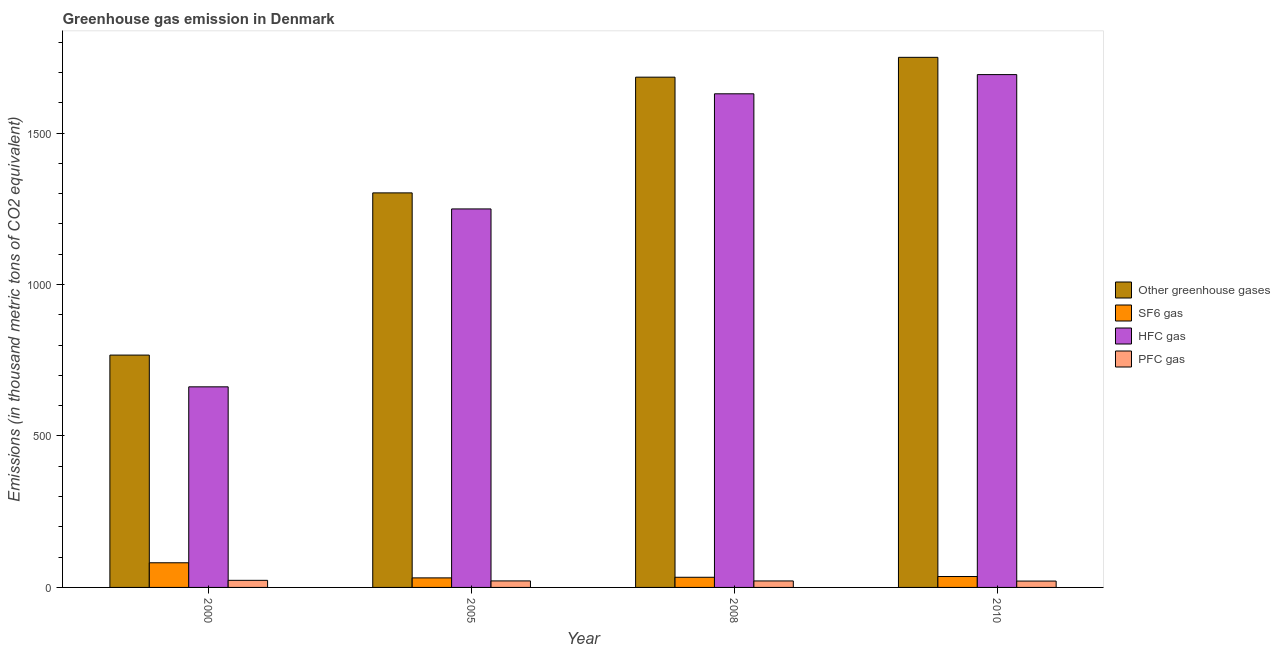How many groups of bars are there?
Give a very brief answer. 4. How many bars are there on the 3rd tick from the right?
Your response must be concise. 4. What is the emission of greenhouse gases in 2000?
Provide a short and direct response. 767. Across all years, what is the maximum emission of sf6 gas?
Your answer should be very brief. 81.4. Across all years, what is the minimum emission of hfc gas?
Provide a succinct answer. 662.2. What is the total emission of hfc gas in the graph?
Your response must be concise. 5234.3. What is the difference between the emission of hfc gas in 2008 and the emission of sf6 gas in 2000?
Your answer should be compact. 967.4. What is the average emission of greenhouse gases per year?
Your answer should be compact. 1376. In the year 2008, what is the difference between the emission of greenhouse gases and emission of hfc gas?
Keep it short and to the point. 0. What is the ratio of the emission of pfc gas in 2008 to that in 2010?
Ensure brevity in your answer.  1.02. Is the difference between the emission of sf6 gas in 2005 and 2010 greater than the difference between the emission of hfc gas in 2005 and 2010?
Your answer should be very brief. No. What is the difference between the highest and the second highest emission of pfc gas?
Provide a succinct answer. 1.9. What is the difference between the highest and the lowest emission of hfc gas?
Give a very brief answer. 1030.8. In how many years, is the emission of pfc gas greater than the average emission of pfc gas taken over all years?
Provide a short and direct response. 1. Is the sum of the emission of greenhouse gases in 2005 and 2010 greater than the maximum emission of pfc gas across all years?
Offer a terse response. Yes. Is it the case that in every year, the sum of the emission of pfc gas and emission of greenhouse gases is greater than the sum of emission of hfc gas and emission of sf6 gas?
Ensure brevity in your answer.  No. What does the 4th bar from the left in 2008 represents?
Ensure brevity in your answer.  PFC gas. What does the 2nd bar from the right in 2000 represents?
Your answer should be compact. HFC gas. Is it the case that in every year, the sum of the emission of greenhouse gases and emission of sf6 gas is greater than the emission of hfc gas?
Offer a terse response. Yes. How many bars are there?
Give a very brief answer. 16. Are all the bars in the graph horizontal?
Ensure brevity in your answer.  No. How many years are there in the graph?
Make the answer very short. 4. Does the graph contain grids?
Give a very brief answer. No. How are the legend labels stacked?
Keep it short and to the point. Vertical. What is the title of the graph?
Your answer should be very brief. Greenhouse gas emission in Denmark. Does "Austria" appear as one of the legend labels in the graph?
Offer a terse response. No. What is the label or title of the Y-axis?
Provide a short and direct response. Emissions (in thousand metric tons of CO2 equivalent). What is the Emissions (in thousand metric tons of CO2 equivalent) in Other greenhouse gases in 2000?
Make the answer very short. 767. What is the Emissions (in thousand metric tons of CO2 equivalent) in SF6 gas in 2000?
Offer a terse response. 81.4. What is the Emissions (in thousand metric tons of CO2 equivalent) of HFC gas in 2000?
Ensure brevity in your answer.  662.2. What is the Emissions (in thousand metric tons of CO2 equivalent) of PFC gas in 2000?
Offer a terse response. 23.4. What is the Emissions (in thousand metric tons of CO2 equivalent) in Other greenhouse gases in 2005?
Your answer should be very brief. 1302.5. What is the Emissions (in thousand metric tons of CO2 equivalent) of SF6 gas in 2005?
Provide a short and direct response. 31.5. What is the Emissions (in thousand metric tons of CO2 equivalent) of HFC gas in 2005?
Your response must be concise. 1249.5. What is the Emissions (in thousand metric tons of CO2 equivalent) of PFC gas in 2005?
Offer a terse response. 21.5. What is the Emissions (in thousand metric tons of CO2 equivalent) in Other greenhouse gases in 2008?
Offer a terse response. 1684.5. What is the Emissions (in thousand metric tons of CO2 equivalent) of SF6 gas in 2008?
Your response must be concise. 33.5. What is the Emissions (in thousand metric tons of CO2 equivalent) in HFC gas in 2008?
Your response must be concise. 1629.6. What is the Emissions (in thousand metric tons of CO2 equivalent) in PFC gas in 2008?
Keep it short and to the point. 21.4. What is the Emissions (in thousand metric tons of CO2 equivalent) of Other greenhouse gases in 2010?
Your answer should be compact. 1750. What is the Emissions (in thousand metric tons of CO2 equivalent) in SF6 gas in 2010?
Keep it short and to the point. 36. What is the Emissions (in thousand metric tons of CO2 equivalent) of HFC gas in 2010?
Give a very brief answer. 1693. What is the Emissions (in thousand metric tons of CO2 equivalent) of PFC gas in 2010?
Offer a very short reply. 21. Across all years, what is the maximum Emissions (in thousand metric tons of CO2 equivalent) of Other greenhouse gases?
Your answer should be very brief. 1750. Across all years, what is the maximum Emissions (in thousand metric tons of CO2 equivalent) in SF6 gas?
Offer a terse response. 81.4. Across all years, what is the maximum Emissions (in thousand metric tons of CO2 equivalent) of HFC gas?
Your response must be concise. 1693. Across all years, what is the maximum Emissions (in thousand metric tons of CO2 equivalent) in PFC gas?
Make the answer very short. 23.4. Across all years, what is the minimum Emissions (in thousand metric tons of CO2 equivalent) of Other greenhouse gases?
Offer a terse response. 767. Across all years, what is the minimum Emissions (in thousand metric tons of CO2 equivalent) of SF6 gas?
Provide a succinct answer. 31.5. Across all years, what is the minimum Emissions (in thousand metric tons of CO2 equivalent) in HFC gas?
Ensure brevity in your answer.  662.2. What is the total Emissions (in thousand metric tons of CO2 equivalent) of Other greenhouse gases in the graph?
Keep it short and to the point. 5504. What is the total Emissions (in thousand metric tons of CO2 equivalent) in SF6 gas in the graph?
Keep it short and to the point. 182.4. What is the total Emissions (in thousand metric tons of CO2 equivalent) of HFC gas in the graph?
Provide a succinct answer. 5234.3. What is the total Emissions (in thousand metric tons of CO2 equivalent) of PFC gas in the graph?
Provide a short and direct response. 87.3. What is the difference between the Emissions (in thousand metric tons of CO2 equivalent) of Other greenhouse gases in 2000 and that in 2005?
Your response must be concise. -535.5. What is the difference between the Emissions (in thousand metric tons of CO2 equivalent) in SF6 gas in 2000 and that in 2005?
Ensure brevity in your answer.  49.9. What is the difference between the Emissions (in thousand metric tons of CO2 equivalent) in HFC gas in 2000 and that in 2005?
Give a very brief answer. -587.3. What is the difference between the Emissions (in thousand metric tons of CO2 equivalent) of PFC gas in 2000 and that in 2005?
Offer a terse response. 1.9. What is the difference between the Emissions (in thousand metric tons of CO2 equivalent) of Other greenhouse gases in 2000 and that in 2008?
Keep it short and to the point. -917.5. What is the difference between the Emissions (in thousand metric tons of CO2 equivalent) in SF6 gas in 2000 and that in 2008?
Provide a short and direct response. 47.9. What is the difference between the Emissions (in thousand metric tons of CO2 equivalent) of HFC gas in 2000 and that in 2008?
Your answer should be very brief. -967.4. What is the difference between the Emissions (in thousand metric tons of CO2 equivalent) in PFC gas in 2000 and that in 2008?
Offer a terse response. 2. What is the difference between the Emissions (in thousand metric tons of CO2 equivalent) in Other greenhouse gases in 2000 and that in 2010?
Make the answer very short. -983. What is the difference between the Emissions (in thousand metric tons of CO2 equivalent) in SF6 gas in 2000 and that in 2010?
Your answer should be very brief. 45.4. What is the difference between the Emissions (in thousand metric tons of CO2 equivalent) of HFC gas in 2000 and that in 2010?
Your answer should be compact. -1030.8. What is the difference between the Emissions (in thousand metric tons of CO2 equivalent) of PFC gas in 2000 and that in 2010?
Your answer should be very brief. 2.4. What is the difference between the Emissions (in thousand metric tons of CO2 equivalent) of Other greenhouse gases in 2005 and that in 2008?
Provide a succinct answer. -382. What is the difference between the Emissions (in thousand metric tons of CO2 equivalent) in HFC gas in 2005 and that in 2008?
Give a very brief answer. -380.1. What is the difference between the Emissions (in thousand metric tons of CO2 equivalent) in Other greenhouse gases in 2005 and that in 2010?
Make the answer very short. -447.5. What is the difference between the Emissions (in thousand metric tons of CO2 equivalent) of SF6 gas in 2005 and that in 2010?
Give a very brief answer. -4.5. What is the difference between the Emissions (in thousand metric tons of CO2 equivalent) in HFC gas in 2005 and that in 2010?
Make the answer very short. -443.5. What is the difference between the Emissions (in thousand metric tons of CO2 equivalent) of PFC gas in 2005 and that in 2010?
Provide a succinct answer. 0.5. What is the difference between the Emissions (in thousand metric tons of CO2 equivalent) of Other greenhouse gases in 2008 and that in 2010?
Provide a short and direct response. -65.5. What is the difference between the Emissions (in thousand metric tons of CO2 equivalent) of HFC gas in 2008 and that in 2010?
Your answer should be compact. -63.4. What is the difference between the Emissions (in thousand metric tons of CO2 equivalent) in PFC gas in 2008 and that in 2010?
Offer a very short reply. 0.4. What is the difference between the Emissions (in thousand metric tons of CO2 equivalent) of Other greenhouse gases in 2000 and the Emissions (in thousand metric tons of CO2 equivalent) of SF6 gas in 2005?
Provide a short and direct response. 735.5. What is the difference between the Emissions (in thousand metric tons of CO2 equivalent) in Other greenhouse gases in 2000 and the Emissions (in thousand metric tons of CO2 equivalent) in HFC gas in 2005?
Your response must be concise. -482.5. What is the difference between the Emissions (in thousand metric tons of CO2 equivalent) of Other greenhouse gases in 2000 and the Emissions (in thousand metric tons of CO2 equivalent) of PFC gas in 2005?
Your response must be concise. 745.5. What is the difference between the Emissions (in thousand metric tons of CO2 equivalent) in SF6 gas in 2000 and the Emissions (in thousand metric tons of CO2 equivalent) in HFC gas in 2005?
Provide a succinct answer. -1168.1. What is the difference between the Emissions (in thousand metric tons of CO2 equivalent) in SF6 gas in 2000 and the Emissions (in thousand metric tons of CO2 equivalent) in PFC gas in 2005?
Your response must be concise. 59.9. What is the difference between the Emissions (in thousand metric tons of CO2 equivalent) of HFC gas in 2000 and the Emissions (in thousand metric tons of CO2 equivalent) of PFC gas in 2005?
Give a very brief answer. 640.7. What is the difference between the Emissions (in thousand metric tons of CO2 equivalent) of Other greenhouse gases in 2000 and the Emissions (in thousand metric tons of CO2 equivalent) of SF6 gas in 2008?
Your answer should be very brief. 733.5. What is the difference between the Emissions (in thousand metric tons of CO2 equivalent) of Other greenhouse gases in 2000 and the Emissions (in thousand metric tons of CO2 equivalent) of HFC gas in 2008?
Keep it short and to the point. -862.6. What is the difference between the Emissions (in thousand metric tons of CO2 equivalent) of Other greenhouse gases in 2000 and the Emissions (in thousand metric tons of CO2 equivalent) of PFC gas in 2008?
Give a very brief answer. 745.6. What is the difference between the Emissions (in thousand metric tons of CO2 equivalent) in SF6 gas in 2000 and the Emissions (in thousand metric tons of CO2 equivalent) in HFC gas in 2008?
Offer a very short reply. -1548.2. What is the difference between the Emissions (in thousand metric tons of CO2 equivalent) of HFC gas in 2000 and the Emissions (in thousand metric tons of CO2 equivalent) of PFC gas in 2008?
Your response must be concise. 640.8. What is the difference between the Emissions (in thousand metric tons of CO2 equivalent) of Other greenhouse gases in 2000 and the Emissions (in thousand metric tons of CO2 equivalent) of SF6 gas in 2010?
Offer a very short reply. 731. What is the difference between the Emissions (in thousand metric tons of CO2 equivalent) in Other greenhouse gases in 2000 and the Emissions (in thousand metric tons of CO2 equivalent) in HFC gas in 2010?
Keep it short and to the point. -926. What is the difference between the Emissions (in thousand metric tons of CO2 equivalent) of Other greenhouse gases in 2000 and the Emissions (in thousand metric tons of CO2 equivalent) of PFC gas in 2010?
Your response must be concise. 746. What is the difference between the Emissions (in thousand metric tons of CO2 equivalent) in SF6 gas in 2000 and the Emissions (in thousand metric tons of CO2 equivalent) in HFC gas in 2010?
Your answer should be compact. -1611.6. What is the difference between the Emissions (in thousand metric tons of CO2 equivalent) in SF6 gas in 2000 and the Emissions (in thousand metric tons of CO2 equivalent) in PFC gas in 2010?
Ensure brevity in your answer.  60.4. What is the difference between the Emissions (in thousand metric tons of CO2 equivalent) in HFC gas in 2000 and the Emissions (in thousand metric tons of CO2 equivalent) in PFC gas in 2010?
Your response must be concise. 641.2. What is the difference between the Emissions (in thousand metric tons of CO2 equivalent) of Other greenhouse gases in 2005 and the Emissions (in thousand metric tons of CO2 equivalent) of SF6 gas in 2008?
Your answer should be very brief. 1269. What is the difference between the Emissions (in thousand metric tons of CO2 equivalent) in Other greenhouse gases in 2005 and the Emissions (in thousand metric tons of CO2 equivalent) in HFC gas in 2008?
Ensure brevity in your answer.  -327.1. What is the difference between the Emissions (in thousand metric tons of CO2 equivalent) in Other greenhouse gases in 2005 and the Emissions (in thousand metric tons of CO2 equivalent) in PFC gas in 2008?
Offer a very short reply. 1281.1. What is the difference between the Emissions (in thousand metric tons of CO2 equivalent) of SF6 gas in 2005 and the Emissions (in thousand metric tons of CO2 equivalent) of HFC gas in 2008?
Provide a short and direct response. -1598.1. What is the difference between the Emissions (in thousand metric tons of CO2 equivalent) of HFC gas in 2005 and the Emissions (in thousand metric tons of CO2 equivalent) of PFC gas in 2008?
Offer a very short reply. 1228.1. What is the difference between the Emissions (in thousand metric tons of CO2 equivalent) of Other greenhouse gases in 2005 and the Emissions (in thousand metric tons of CO2 equivalent) of SF6 gas in 2010?
Ensure brevity in your answer.  1266.5. What is the difference between the Emissions (in thousand metric tons of CO2 equivalent) of Other greenhouse gases in 2005 and the Emissions (in thousand metric tons of CO2 equivalent) of HFC gas in 2010?
Ensure brevity in your answer.  -390.5. What is the difference between the Emissions (in thousand metric tons of CO2 equivalent) in Other greenhouse gases in 2005 and the Emissions (in thousand metric tons of CO2 equivalent) in PFC gas in 2010?
Provide a short and direct response. 1281.5. What is the difference between the Emissions (in thousand metric tons of CO2 equivalent) in SF6 gas in 2005 and the Emissions (in thousand metric tons of CO2 equivalent) in HFC gas in 2010?
Your answer should be compact. -1661.5. What is the difference between the Emissions (in thousand metric tons of CO2 equivalent) of SF6 gas in 2005 and the Emissions (in thousand metric tons of CO2 equivalent) of PFC gas in 2010?
Provide a short and direct response. 10.5. What is the difference between the Emissions (in thousand metric tons of CO2 equivalent) in HFC gas in 2005 and the Emissions (in thousand metric tons of CO2 equivalent) in PFC gas in 2010?
Offer a very short reply. 1228.5. What is the difference between the Emissions (in thousand metric tons of CO2 equivalent) in Other greenhouse gases in 2008 and the Emissions (in thousand metric tons of CO2 equivalent) in SF6 gas in 2010?
Offer a very short reply. 1648.5. What is the difference between the Emissions (in thousand metric tons of CO2 equivalent) in Other greenhouse gases in 2008 and the Emissions (in thousand metric tons of CO2 equivalent) in PFC gas in 2010?
Provide a short and direct response. 1663.5. What is the difference between the Emissions (in thousand metric tons of CO2 equivalent) of SF6 gas in 2008 and the Emissions (in thousand metric tons of CO2 equivalent) of HFC gas in 2010?
Your answer should be very brief. -1659.5. What is the difference between the Emissions (in thousand metric tons of CO2 equivalent) in SF6 gas in 2008 and the Emissions (in thousand metric tons of CO2 equivalent) in PFC gas in 2010?
Offer a terse response. 12.5. What is the difference between the Emissions (in thousand metric tons of CO2 equivalent) in HFC gas in 2008 and the Emissions (in thousand metric tons of CO2 equivalent) in PFC gas in 2010?
Keep it short and to the point. 1608.6. What is the average Emissions (in thousand metric tons of CO2 equivalent) of Other greenhouse gases per year?
Your answer should be compact. 1376. What is the average Emissions (in thousand metric tons of CO2 equivalent) of SF6 gas per year?
Ensure brevity in your answer.  45.6. What is the average Emissions (in thousand metric tons of CO2 equivalent) of HFC gas per year?
Offer a very short reply. 1308.58. What is the average Emissions (in thousand metric tons of CO2 equivalent) in PFC gas per year?
Your answer should be compact. 21.82. In the year 2000, what is the difference between the Emissions (in thousand metric tons of CO2 equivalent) of Other greenhouse gases and Emissions (in thousand metric tons of CO2 equivalent) of SF6 gas?
Give a very brief answer. 685.6. In the year 2000, what is the difference between the Emissions (in thousand metric tons of CO2 equivalent) in Other greenhouse gases and Emissions (in thousand metric tons of CO2 equivalent) in HFC gas?
Keep it short and to the point. 104.8. In the year 2000, what is the difference between the Emissions (in thousand metric tons of CO2 equivalent) in Other greenhouse gases and Emissions (in thousand metric tons of CO2 equivalent) in PFC gas?
Provide a short and direct response. 743.6. In the year 2000, what is the difference between the Emissions (in thousand metric tons of CO2 equivalent) of SF6 gas and Emissions (in thousand metric tons of CO2 equivalent) of HFC gas?
Give a very brief answer. -580.8. In the year 2000, what is the difference between the Emissions (in thousand metric tons of CO2 equivalent) of SF6 gas and Emissions (in thousand metric tons of CO2 equivalent) of PFC gas?
Your answer should be very brief. 58. In the year 2000, what is the difference between the Emissions (in thousand metric tons of CO2 equivalent) in HFC gas and Emissions (in thousand metric tons of CO2 equivalent) in PFC gas?
Give a very brief answer. 638.8. In the year 2005, what is the difference between the Emissions (in thousand metric tons of CO2 equivalent) of Other greenhouse gases and Emissions (in thousand metric tons of CO2 equivalent) of SF6 gas?
Give a very brief answer. 1271. In the year 2005, what is the difference between the Emissions (in thousand metric tons of CO2 equivalent) of Other greenhouse gases and Emissions (in thousand metric tons of CO2 equivalent) of HFC gas?
Make the answer very short. 53. In the year 2005, what is the difference between the Emissions (in thousand metric tons of CO2 equivalent) in Other greenhouse gases and Emissions (in thousand metric tons of CO2 equivalent) in PFC gas?
Give a very brief answer. 1281. In the year 2005, what is the difference between the Emissions (in thousand metric tons of CO2 equivalent) in SF6 gas and Emissions (in thousand metric tons of CO2 equivalent) in HFC gas?
Offer a very short reply. -1218. In the year 2005, what is the difference between the Emissions (in thousand metric tons of CO2 equivalent) of SF6 gas and Emissions (in thousand metric tons of CO2 equivalent) of PFC gas?
Offer a very short reply. 10. In the year 2005, what is the difference between the Emissions (in thousand metric tons of CO2 equivalent) in HFC gas and Emissions (in thousand metric tons of CO2 equivalent) in PFC gas?
Your response must be concise. 1228. In the year 2008, what is the difference between the Emissions (in thousand metric tons of CO2 equivalent) of Other greenhouse gases and Emissions (in thousand metric tons of CO2 equivalent) of SF6 gas?
Offer a terse response. 1651. In the year 2008, what is the difference between the Emissions (in thousand metric tons of CO2 equivalent) in Other greenhouse gases and Emissions (in thousand metric tons of CO2 equivalent) in HFC gas?
Offer a very short reply. 54.9. In the year 2008, what is the difference between the Emissions (in thousand metric tons of CO2 equivalent) in Other greenhouse gases and Emissions (in thousand metric tons of CO2 equivalent) in PFC gas?
Your response must be concise. 1663.1. In the year 2008, what is the difference between the Emissions (in thousand metric tons of CO2 equivalent) of SF6 gas and Emissions (in thousand metric tons of CO2 equivalent) of HFC gas?
Ensure brevity in your answer.  -1596.1. In the year 2008, what is the difference between the Emissions (in thousand metric tons of CO2 equivalent) in SF6 gas and Emissions (in thousand metric tons of CO2 equivalent) in PFC gas?
Provide a short and direct response. 12.1. In the year 2008, what is the difference between the Emissions (in thousand metric tons of CO2 equivalent) of HFC gas and Emissions (in thousand metric tons of CO2 equivalent) of PFC gas?
Offer a very short reply. 1608.2. In the year 2010, what is the difference between the Emissions (in thousand metric tons of CO2 equivalent) in Other greenhouse gases and Emissions (in thousand metric tons of CO2 equivalent) in SF6 gas?
Ensure brevity in your answer.  1714. In the year 2010, what is the difference between the Emissions (in thousand metric tons of CO2 equivalent) of Other greenhouse gases and Emissions (in thousand metric tons of CO2 equivalent) of PFC gas?
Your answer should be very brief. 1729. In the year 2010, what is the difference between the Emissions (in thousand metric tons of CO2 equivalent) of SF6 gas and Emissions (in thousand metric tons of CO2 equivalent) of HFC gas?
Offer a terse response. -1657. In the year 2010, what is the difference between the Emissions (in thousand metric tons of CO2 equivalent) of HFC gas and Emissions (in thousand metric tons of CO2 equivalent) of PFC gas?
Offer a very short reply. 1672. What is the ratio of the Emissions (in thousand metric tons of CO2 equivalent) of Other greenhouse gases in 2000 to that in 2005?
Keep it short and to the point. 0.59. What is the ratio of the Emissions (in thousand metric tons of CO2 equivalent) in SF6 gas in 2000 to that in 2005?
Give a very brief answer. 2.58. What is the ratio of the Emissions (in thousand metric tons of CO2 equivalent) of HFC gas in 2000 to that in 2005?
Provide a short and direct response. 0.53. What is the ratio of the Emissions (in thousand metric tons of CO2 equivalent) in PFC gas in 2000 to that in 2005?
Give a very brief answer. 1.09. What is the ratio of the Emissions (in thousand metric tons of CO2 equivalent) of Other greenhouse gases in 2000 to that in 2008?
Provide a short and direct response. 0.46. What is the ratio of the Emissions (in thousand metric tons of CO2 equivalent) in SF6 gas in 2000 to that in 2008?
Offer a very short reply. 2.43. What is the ratio of the Emissions (in thousand metric tons of CO2 equivalent) of HFC gas in 2000 to that in 2008?
Offer a very short reply. 0.41. What is the ratio of the Emissions (in thousand metric tons of CO2 equivalent) in PFC gas in 2000 to that in 2008?
Keep it short and to the point. 1.09. What is the ratio of the Emissions (in thousand metric tons of CO2 equivalent) of Other greenhouse gases in 2000 to that in 2010?
Your answer should be compact. 0.44. What is the ratio of the Emissions (in thousand metric tons of CO2 equivalent) in SF6 gas in 2000 to that in 2010?
Provide a succinct answer. 2.26. What is the ratio of the Emissions (in thousand metric tons of CO2 equivalent) in HFC gas in 2000 to that in 2010?
Your response must be concise. 0.39. What is the ratio of the Emissions (in thousand metric tons of CO2 equivalent) of PFC gas in 2000 to that in 2010?
Your answer should be compact. 1.11. What is the ratio of the Emissions (in thousand metric tons of CO2 equivalent) of Other greenhouse gases in 2005 to that in 2008?
Offer a terse response. 0.77. What is the ratio of the Emissions (in thousand metric tons of CO2 equivalent) of SF6 gas in 2005 to that in 2008?
Keep it short and to the point. 0.94. What is the ratio of the Emissions (in thousand metric tons of CO2 equivalent) in HFC gas in 2005 to that in 2008?
Give a very brief answer. 0.77. What is the ratio of the Emissions (in thousand metric tons of CO2 equivalent) of PFC gas in 2005 to that in 2008?
Make the answer very short. 1. What is the ratio of the Emissions (in thousand metric tons of CO2 equivalent) of Other greenhouse gases in 2005 to that in 2010?
Make the answer very short. 0.74. What is the ratio of the Emissions (in thousand metric tons of CO2 equivalent) of HFC gas in 2005 to that in 2010?
Offer a very short reply. 0.74. What is the ratio of the Emissions (in thousand metric tons of CO2 equivalent) of PFC gas in 2005 to that in 2010?
Give a very brief answer. 1.02. What is the ratio of the Emissions (in thousand metric tons of CO2 equivalent) of Other greenhouse gases in 2008 to that in 2010?
Your answer should be compact. 0.96. What is the ratio of the Emissions (in thousand metric tons of CO2 equivalent) of SF6 gas in 2008 to that in 2010?
Provide a succinct answer. 0.93. What is the ratio of the Emissions (in thousand metric tons of CO2 equivalent) in HFC gas in 2008 to that in 2010?
Ensure brevity in your answer.  0.96. What is the ratio of the Emissions (in thousand metric tons of CO2 equivalent) in PFC gas in 2008 to that in 2010?
Keep it short and to the point. 1.02. What is the difference between the highest and the second highest Emissions (in thousand metric tons of CO2 equivalent) of Other greenhouse gases?
Provide a short and direct response. 65.5. What is the difference between the highest and the second highest Emissions (in thousand metric tons of CO2 equivalent) in SF6 gas?
Offer a terse response. 45.4. What is the difference between the highest and the second highest Emissions (in thousand metric tons of CO2 equivalent) of HFC gas?
Make the answer very short. 63.4. What is the difference between the highest and the second highest Emissions (in thousand metric tons of CO2 equivalent) of PFC gas?
Keep it short and to the point. 1.9. What is the difference between the highest and the lowest Emissions (in thousand metric tons of CO2 equivalent) of Other greenhouse gases?
Your response must be concise. 983. What is the difference between the highest and the lowest Emissions (in thousand metric tons of CO2 equivalent) of SF6 gas?
Offer a terse response. 49.9. What is the difference between the highest and the lowest Emissions (in thousand metric tons of CO2 equivalent) in HFC gas?
Offer a terse response. 1030.8. What is the difference between the highest and the lowest Emissions (in thousand metric tons of CO2 equivalent) in PFC gas?
Your answer should be compact. 2.4. 